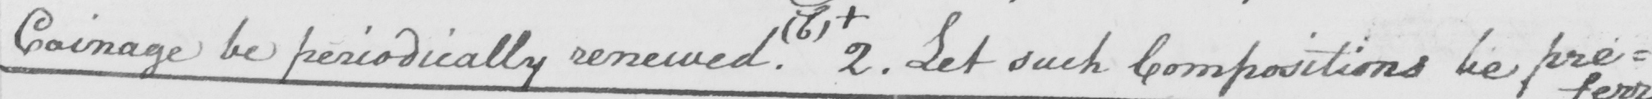Transcribe the text shown in this historical manuscript line. coinage be periodically renewed . ( b )  +  2 . Let such Compositions be pre= 